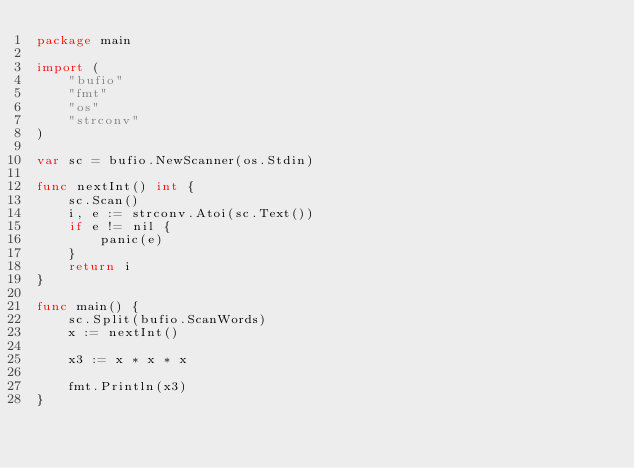Convert code to text. <code><loc_0><loc_0><loc_500><loc_500><_Go_>package main

import (
	"bufio"
	"fmt"
	"os"
	"strconv"
)

var sc = bufio.NewScanner(os.Stdin)

func nextInt() int {
	sc.Scan()
	i, e := strconv.Atoi(sc.Text())
	if e != nil {
		panic(e)
	}
	return i
}

func main() {
	sc.Split(bufio.ScanWords)
	x := nextInt()

	x3 := x * x * x

	fmt.Println(x3)
}

</code> 